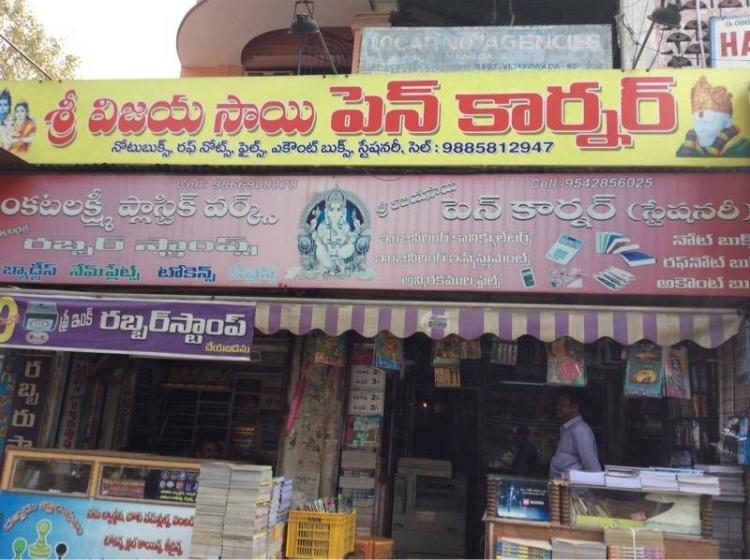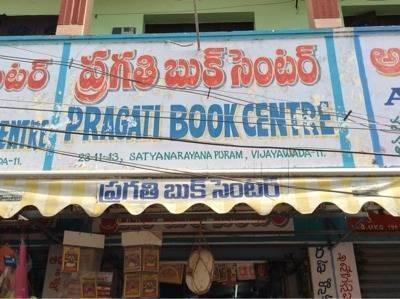The first image is the image on the left, the second image is the image on the right. For the images displayed, is the sentence "There are more than half a dozen people standing around in the image on the left." factually correct? Answer yes or no. No. The first image is the image on the left, the second image is the image on the right. Given the left and right images, does the statement "An image shows multiple people milling around near a store entrance that features red signage." hold true? Answer yes or no. No. 